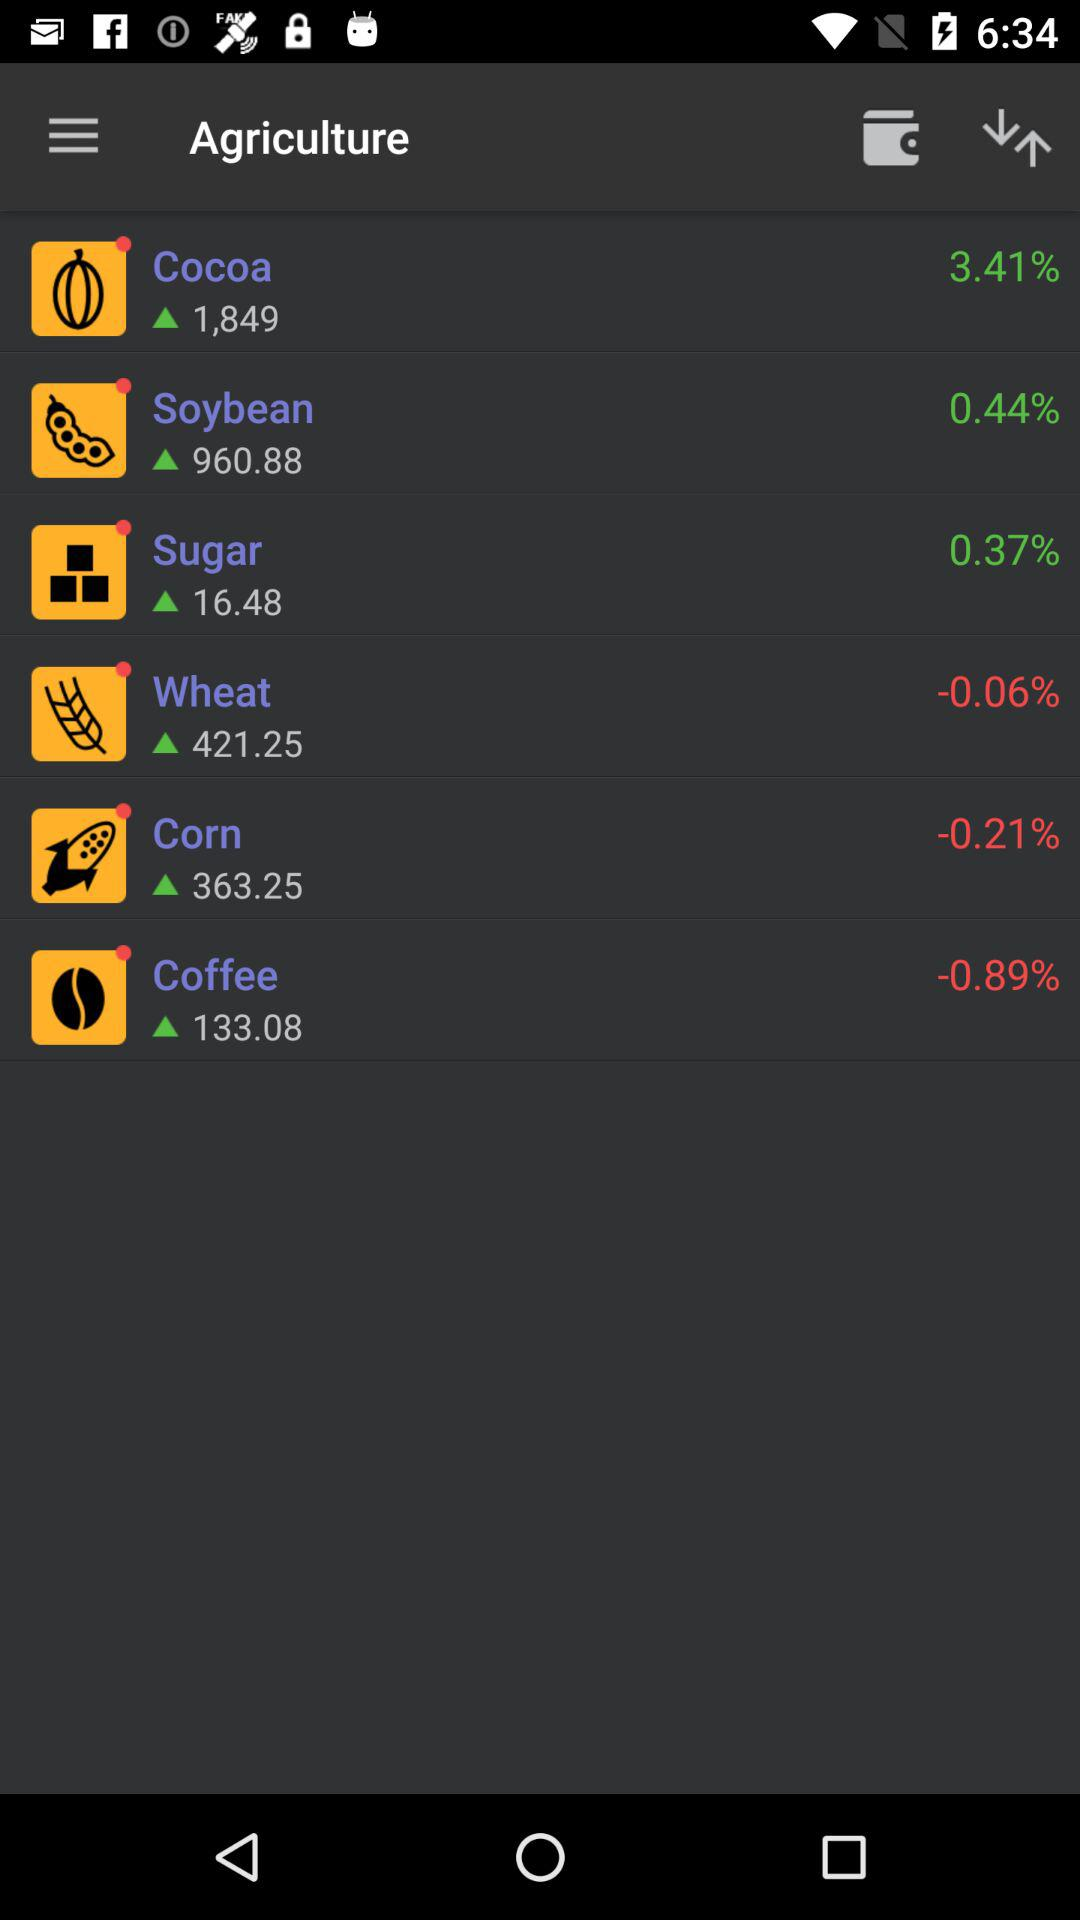What is the percentage increase in "Sugar" production? The percentage increase in "Sugar" production is 0.37%. 